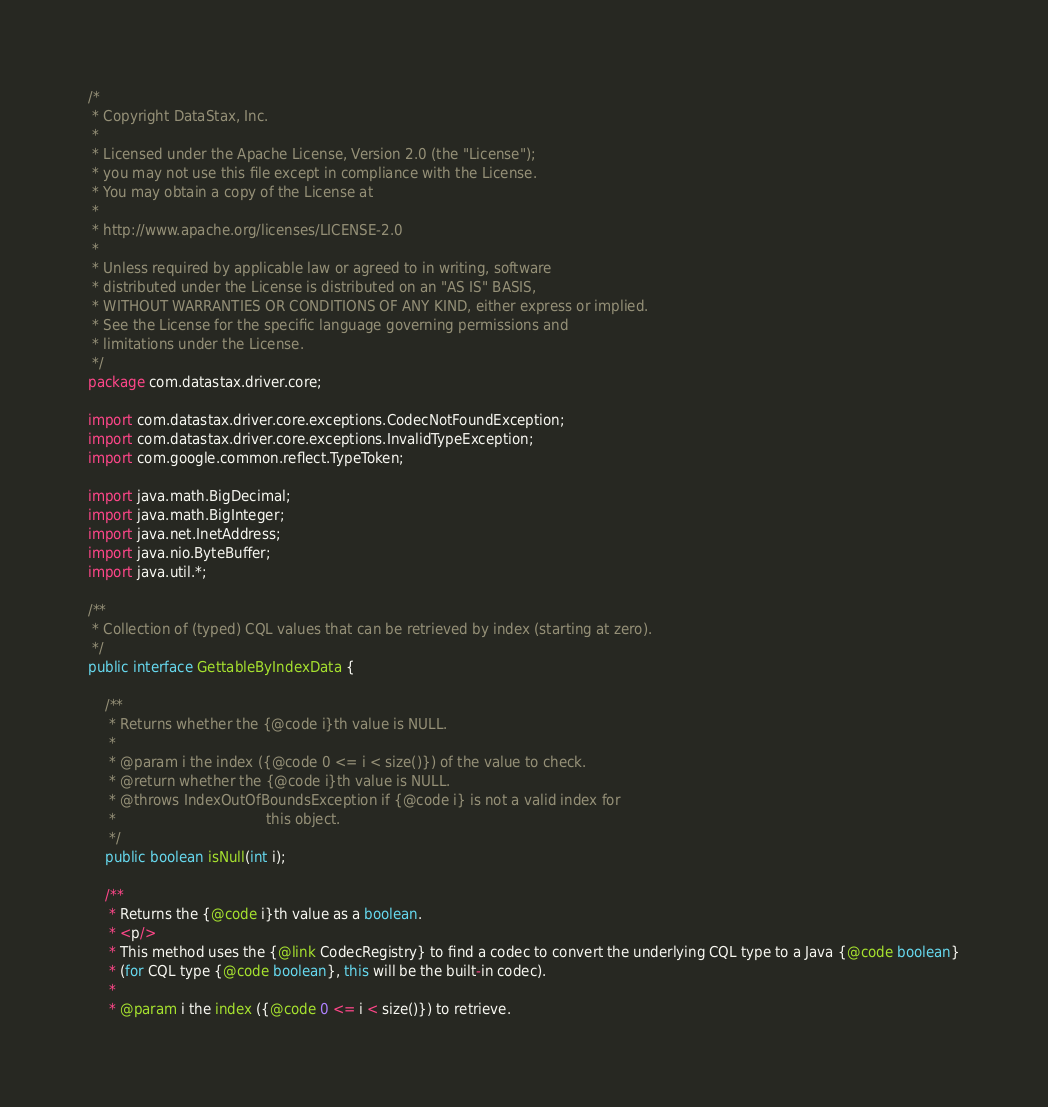Convert code to text. <code><loc_0><loc_0><loc_500><loc_500><_Java_>/*
 * Copyright DataStax, Inc.
 *
 * Licensed under the Apache License, Version 2.0 (the "License");
 * you may not use this file except in compliance with the License.
 * You may obtain a copy of the License at
 *
 * http://www.apache.org/licenses/LICENSE-2.0
 *
 * Unless required by applicable law or agreed to in writing, software
 * distributed under the License is distributed on an "AS IS" BASIS,
 * WITHOUT WARRANTIES OR CONDITIONS OF ANY KIND, either express or implied.
 * See the License for the specific language governing permissions and
 * limitations under the License.
 */
package com.datastax.driver.core;

import com.datastax.driver.core.exceptions.CodecNotFoundException;
import com.datastax.driver.core.exceptions.InvalidTypeException;
import com.google.common.reflect.TypeToken;

import java.math.BigDecimal;
import java.math.BigInteger;
import java.net.InetAddress;
import java.nio.ByteBuffer;
import java.util.*;

/**
 * Collection of (typed) CQL values that can be retrieved by index (starting at zero).
 */
public interface GettableByIndexData {

    /**
     * Returns whether the {@code i}th value is NULL.
     *
     * @param i the index ({@code 0 <= i < size()}) of the value to check.
     * @return whether the {@code i}th value is NULL.
     * @throws IndexOutOfBoundsException if {@code i} is not a valid index for
     *                                   this object.
     */
    public boolean isNull(int i);

    /**
     * Returns the {@code i}th value as a boolean.
     * <p/>
     * This method uses the {@link CodecRegistry} to find a codec to convert the underlying CQL type to a Java {@code boolean}
     * (for CQL type {@code boolean}, this will be the built-in codec).
     *
     * @param i the index ({@code 0 <= i < size()}) to retrieve.</code> 